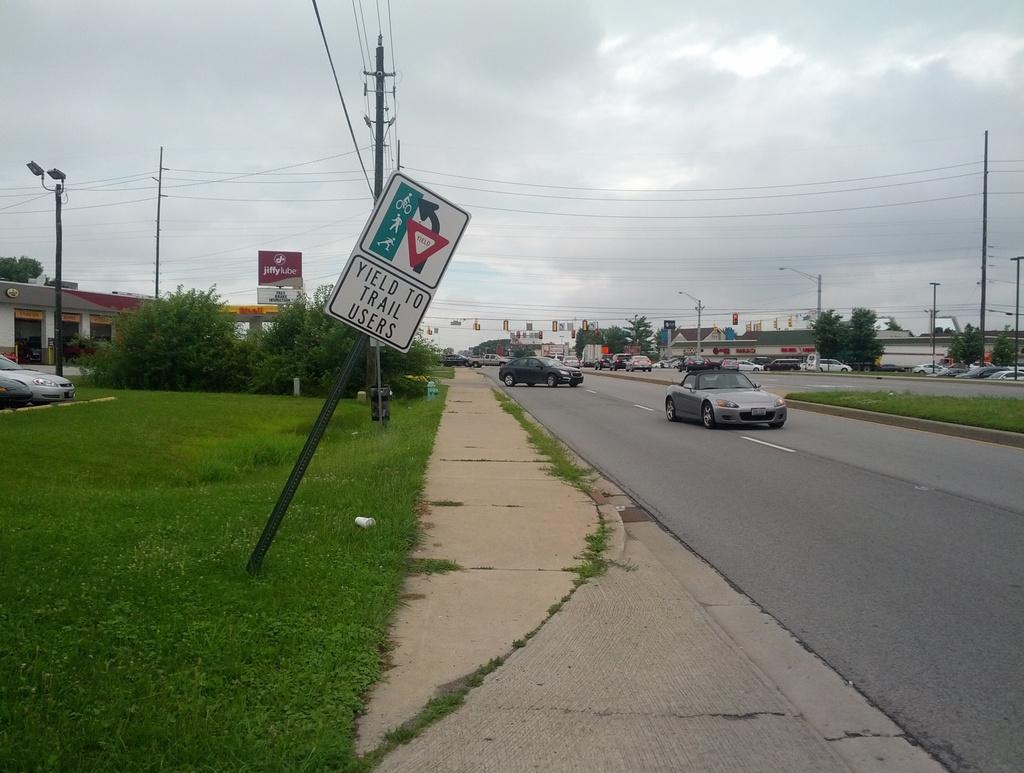Provide a one-sentence caption for the provided image. To cars on a road with a sidewalk and grass to the left and a sign reading Yield to Trail Users slanted on the grass. 